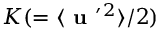Convert formula to latex. <formula><loc_0><loc_0><loc_500><loc_500>K ( = \langle { { u } ^ { \prime ^ { 2 } } \rangle / 2 )</formula> 